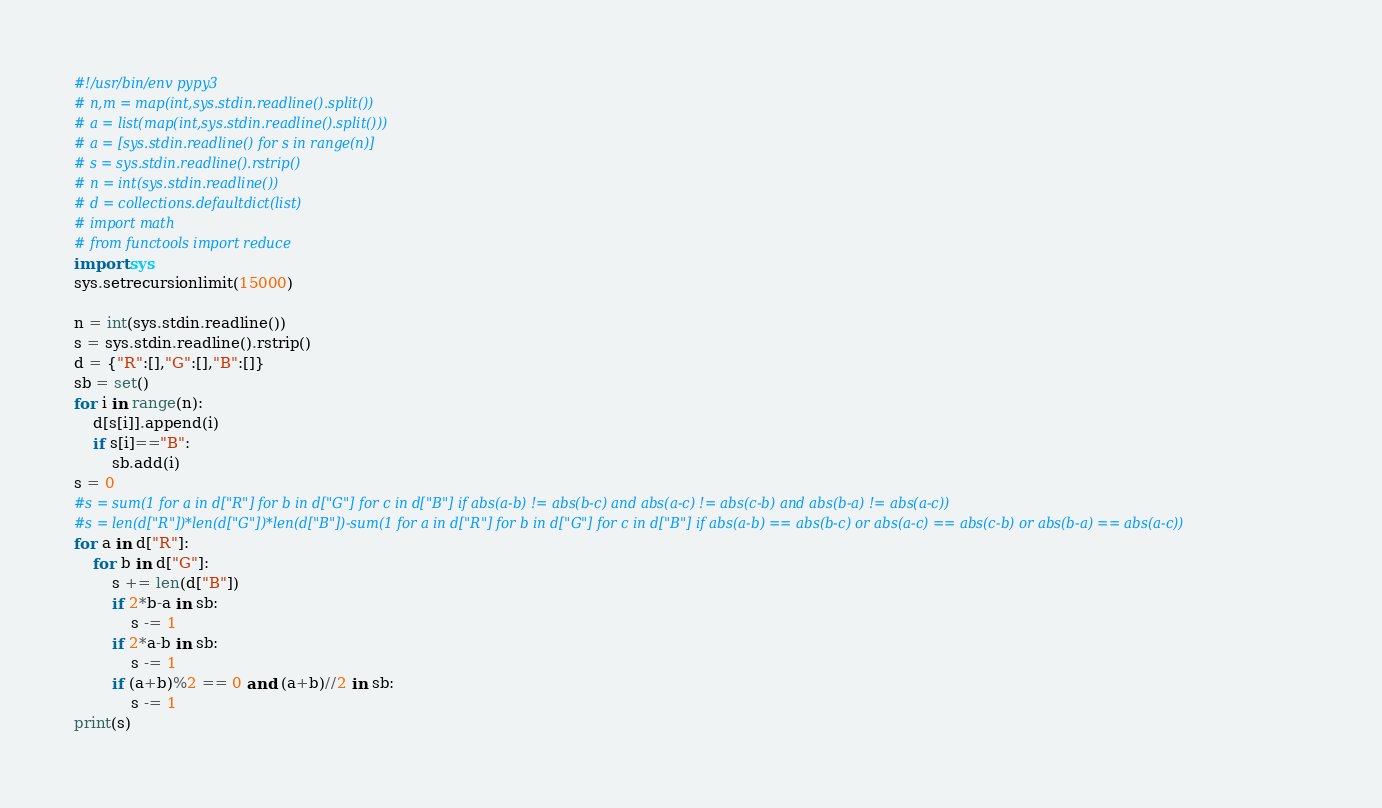<code> <loc_0><loc_0><loc_500><loc_500><_Python_>#!/usr/bin/env pypy3
# n,m = map(int,sys.stdin.readline().split())
# a = list(map(int,sys.stdin.readline().split()))
# a = [sys.stdin.readline() for s in range(n)]
# s = sys.stdin.readline().rstrip()
# n = int(sys.stdin.readline())
# d = collections.defaultdict(list)
# import math
# from functools import reduce
import sys
sys.setrecursionlimit(15000)

n = int(sys.stdin.readline())
s = sys.stdin.readline().rstrip()
d = {"R":[],"G":[],"B":[]}
sb = set()
for i in range(n):
    d[s[i]].append(i)
    if s[i]=="B":
        sb.add(i)
s = 0
#s = sum(1 for a in d["R"] for b in d["G"] for c in d["B"] if abs(a-b) != abs(b-c) and abs(a-c) != abs(c-b) and abs(b-a) != abs(a-c))
#s = len(d["R"])*len(d["G"])*len(d["B"])-sum(1 for a in d["R"] for b in d["G"] for c in d["B"] if abs(a-b) == abs(b-c) or abs(a-c) == abs(c-b) or abs(b-a) == abs(a-c))
for a in d["R"]:
    for b in d["G"]:
        s += len(d["B"])
        if 2*b-a in sb:
            s -= 1
        if 2*a-b in sb:
            s -= 1
        if (a+b)%2 == 0 and (a+b)//2 in sb:
            s -= 1
print(s)</code> 